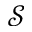Convert formula to latex. <formula><loc_0><loc_0><loc_500><loc_500>\mathcal { S }</formula> 